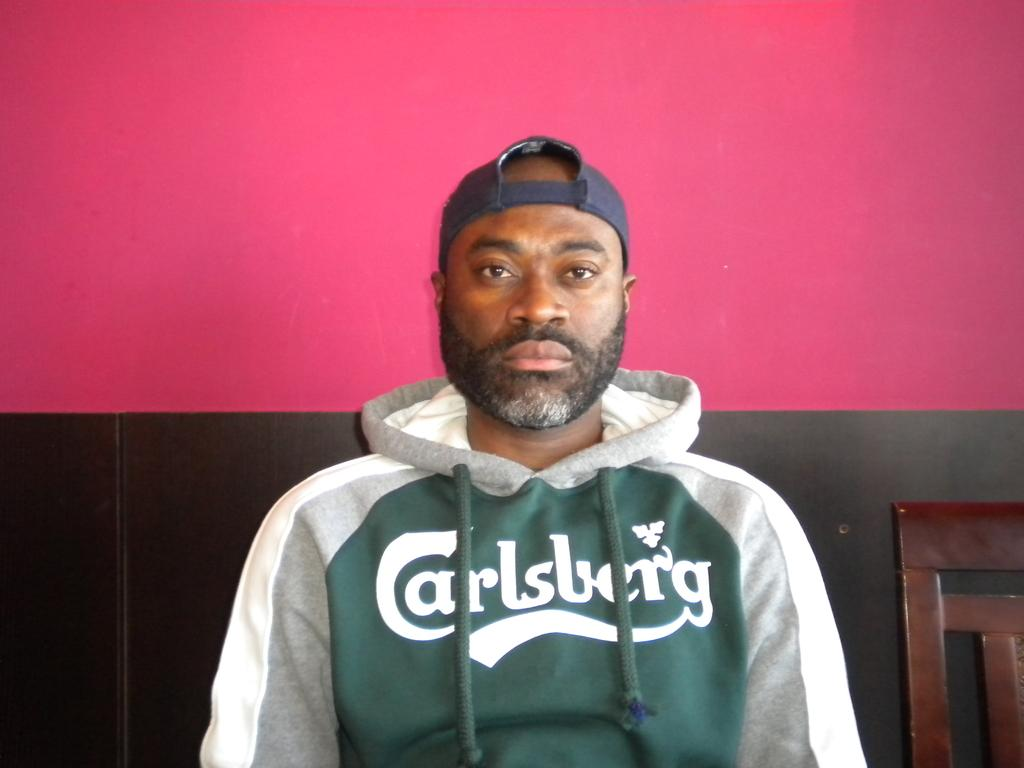Who is present in the image? There is a man in the image. What is the man wearing on his head? The man is wearing a cap. What can be seen behind the man? There is a wall behind the man. Can you describe the colors of the wall? The wall has pink and black colors. Where is the chair located in the image? The chair is in the bottom right corner of the image. What type of straw is the man using to guide the spoon in the image? There is no straw or spoon present in the image, and therefore no such activity can be observed. 